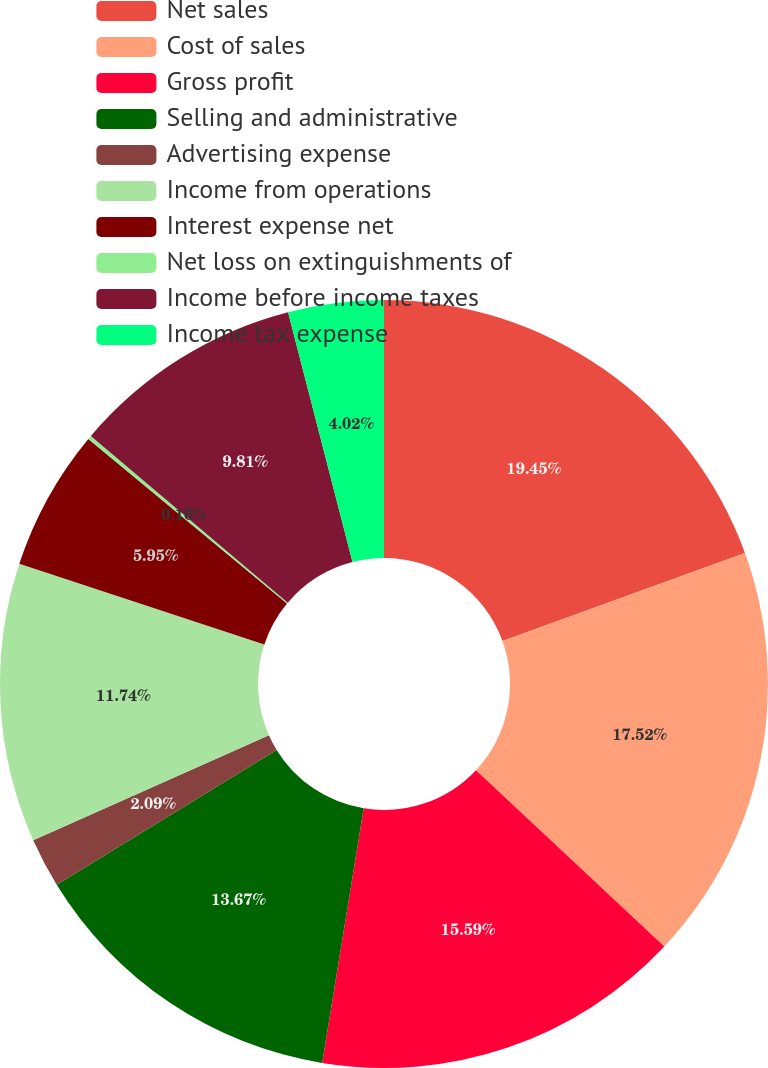Convert chart to OTSL. <chart><loc_0><loc_0><loc_500><loc_500><pie_chart><fcel>Net sales<fcel>Cost of sales<fcel>Gross profit<fcel>Selling and administrative<fcel>Advertising expense<fcel>Income from operations<fcel>Interest expense net<fcel>Net loss on extinguishments of<fcel>Income before income taxes<fcel>Income tax expense<nl><fcel>19.46%<fcel>17.53%<fcel>15.6%<fcel>13.67%<fcel>2.09%<fcel>11.74%<fcel>5.95%<fcel>0.16%<fcel>9.81%<fcel>4.02%<nl></chart> 